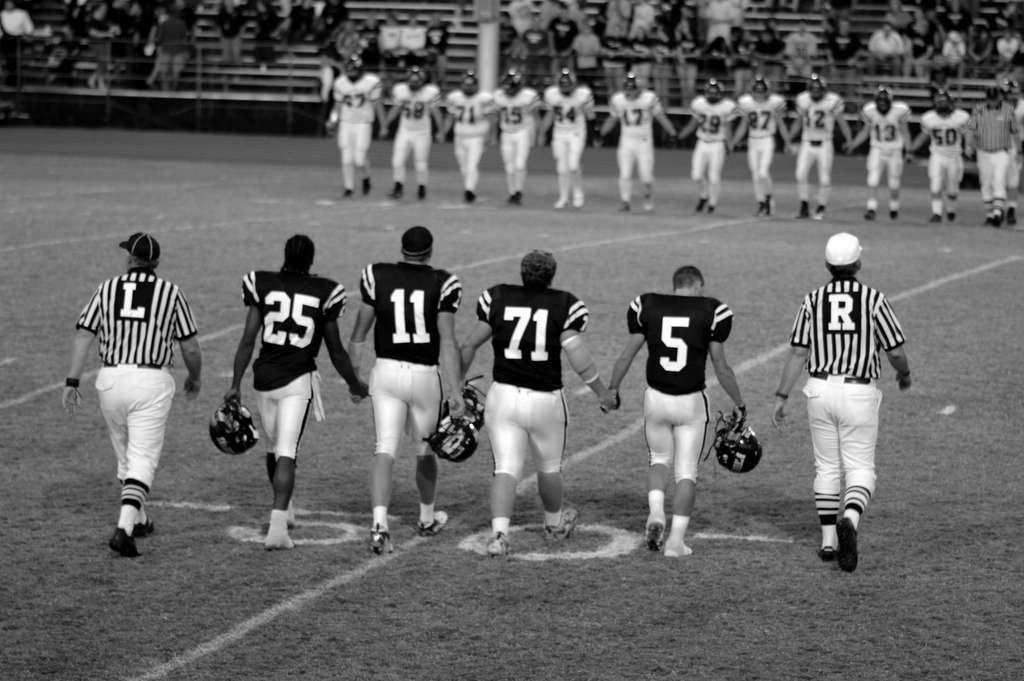Provide a one-sentence caption for the provided image. Football players hold hands while wearing jerseys with numbers like 25, 11, 71, and 5. 